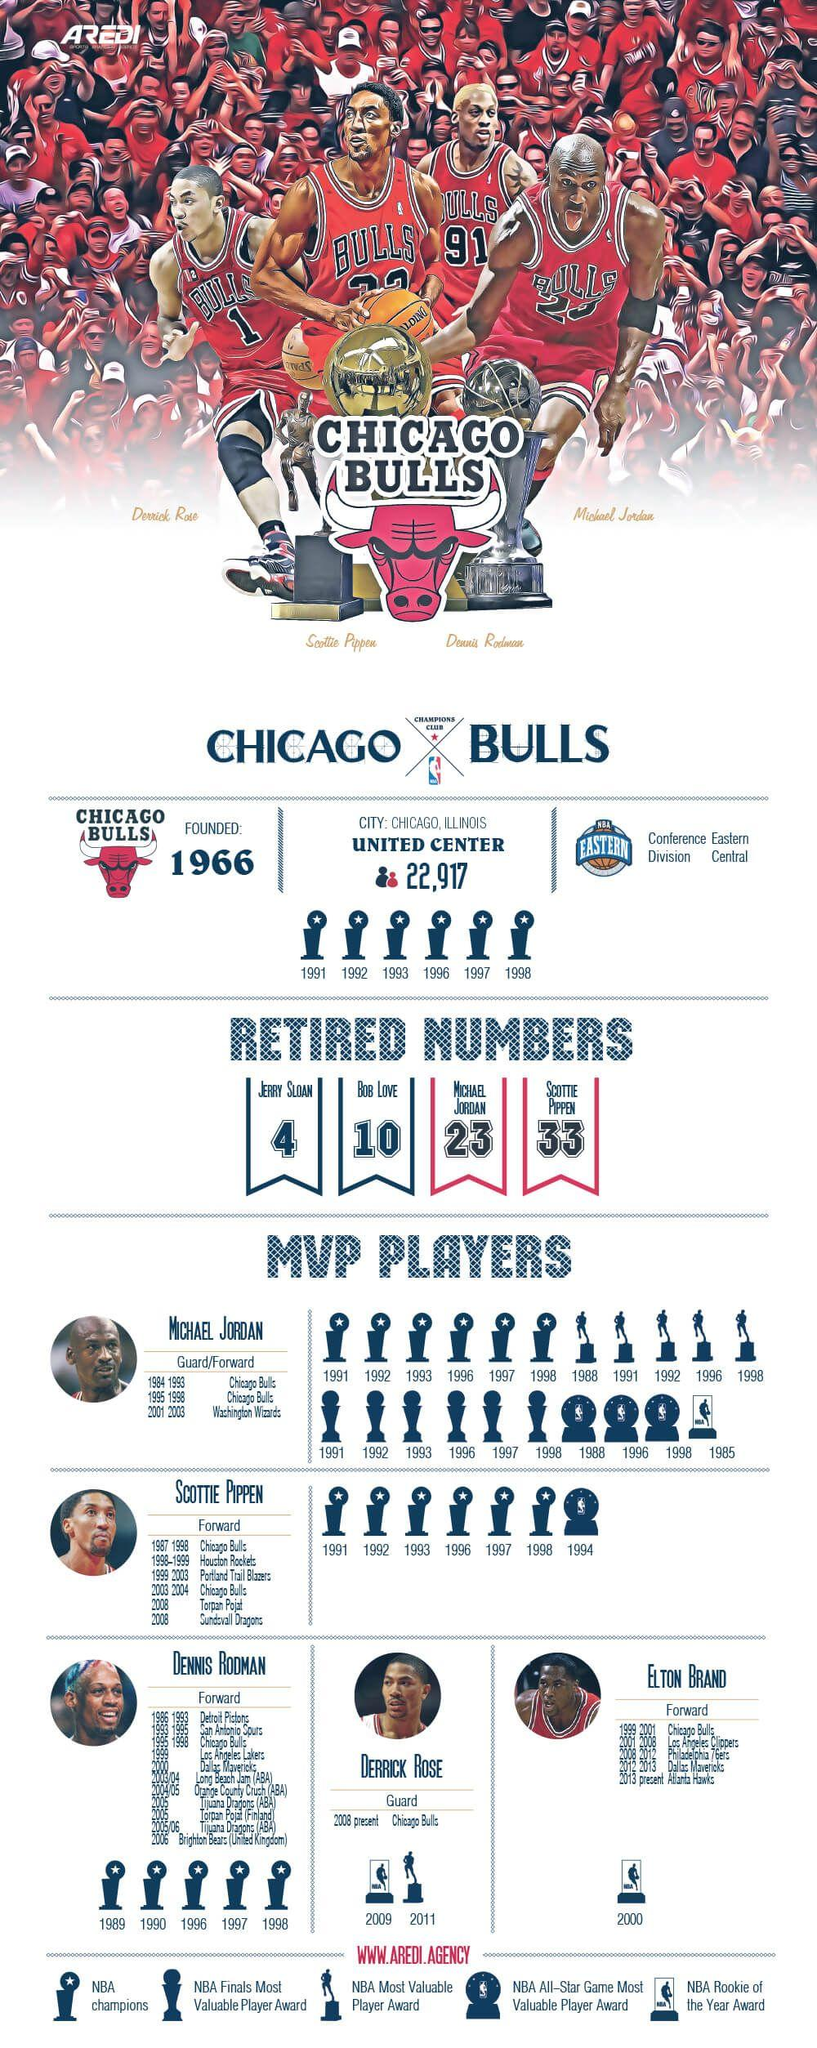Specify some key components in this picture. The number of retired numbers is 4. Scottie Pippen, Elton Brand, and Dennis Rodman are players who primarily play in the forward position. Scottie Pippen played for five different teams throughout his illustrious career in the National Basketball Association (NBA). The T-shirt belonging to Derick Rose has the number "1" printed on it. Derick Rose, who exclusively plays at the guard position, is a talented and skilled player known for his exceptional ball-handling and passing abilities. 